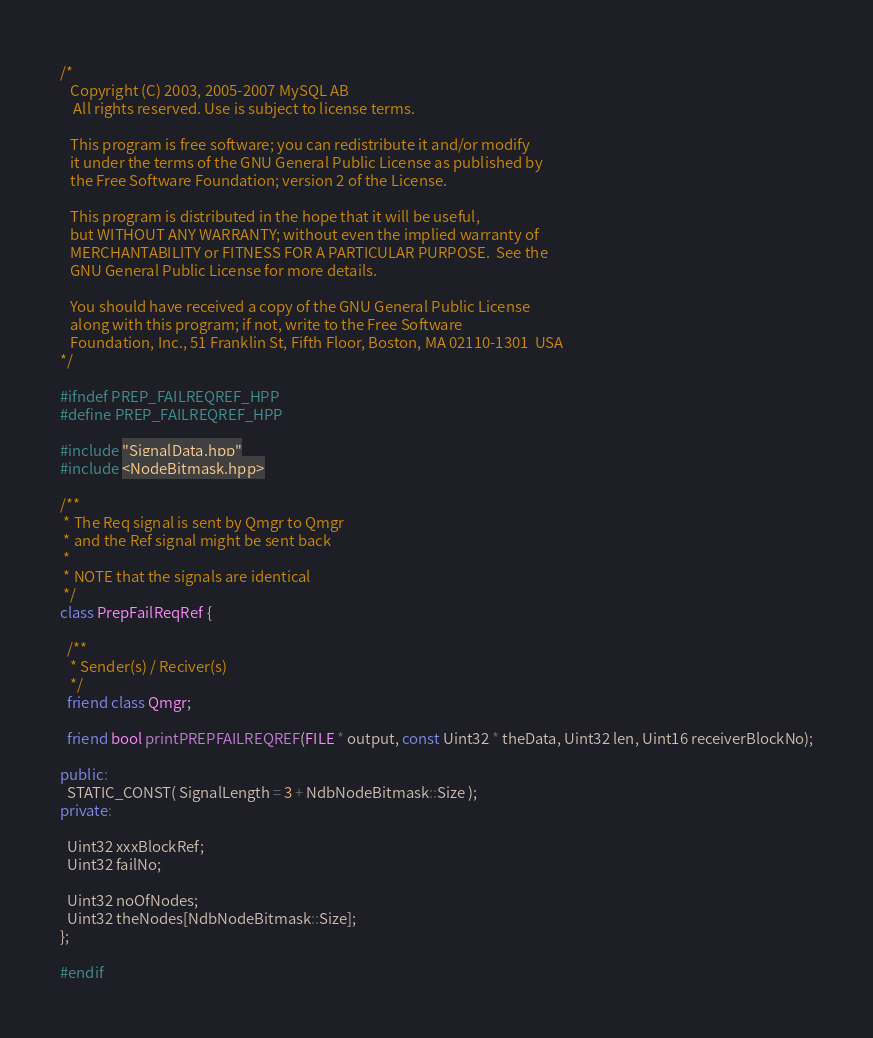Convert code to text. <code><loc_0><loc_0><loc_500><loc_500><_C++_>/*
   Copyright (C) 2003, 2005-2007 MySQL AB
    All rights reserved. Use is subject to license terms.

   This program is free software; you can redistribute it and/or modify
   it under the terms of the GNU General Public License as published by
   the Free Software Foundation; version 2 of the License.

   This program is distributed in the hope that it will be useful,
   but WITHOUT ANY WARRANTY; without even the implied warranty of
   MERCHANTABILITY or FITNESS FOR A PARTICULAR PURPOSE.  See the
   GNU General Public License for more details.

   You should have received a copy of the GNU General Public License
   along with this program; if not, write to the Free Software
   Foundation, Inc., 51 Franklin St, Fifth Floor, Boston, MA 02110-1301  USA
*/

#ifndef PREP_FAILREQREF_HPP
#define PREP_FAILREQREF_HPP

#include "SignalData.hpp"
#include <NodeBitmask.hpp>

/**
 * The Req signal is sent by Qmgr to Qmgr
 * and the Ref signal might be sent back
 *
 * NOTE that the signals are identical
 */
class PrepFailReqRef {

  /**
   * Sender(s) / Reciver(s)
   */
  friend class Qmgr;

  friend bool printPREPFAILREQREF(FILE * output, const Uint32 * theData, Uint32 len, Uint16 receiverBlockNo);
  
public:
  STATIC_CONST( SignalLength = 3 + NdbNodeBitmask::Size );
private:
  
  Uint32 xxxBlockRef;
  Uint32 failNo;
  
  Uint32 noOfNodes;
  Uint32 theNodes[NdbNodeBitmask::Size];
};

#endif
</code> 